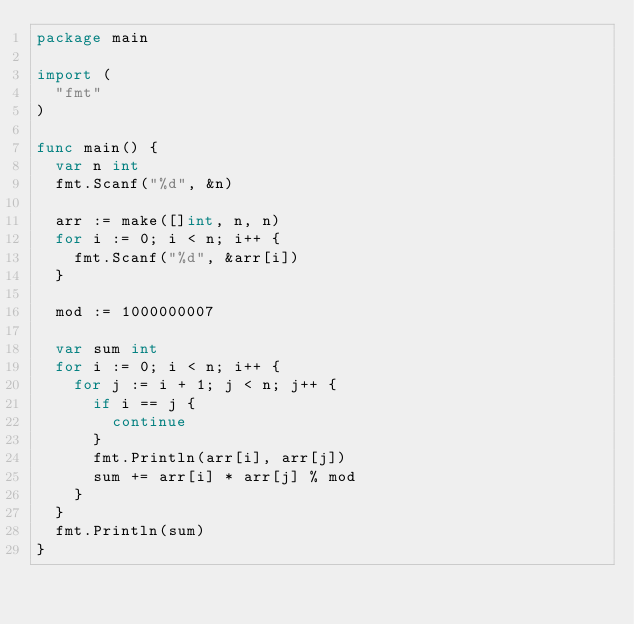<code> <loc_0><loc_0><loc_500><loc_500><_Go_>package main

import (
	"fmt"
)

func main() {
	var n int
	fmt.Scanf("%d", &n)

	arr := make([]int, n, n)
	for i := 0; i < n; i++ {
		fmt.Scanf("%d", &arr[i])
	}

	mod := 1000000007

	var sum int
	for i := 0; i < n; i++ {
		for j := i + 1; j < n; j++ {
			if i == j {
				continue
			}
			fmt.Println(arr[i], arr[j])
			sum += arr[i] * arr[j] % mod
		}
	}
	fmt.Println(sum)
}
</code> 